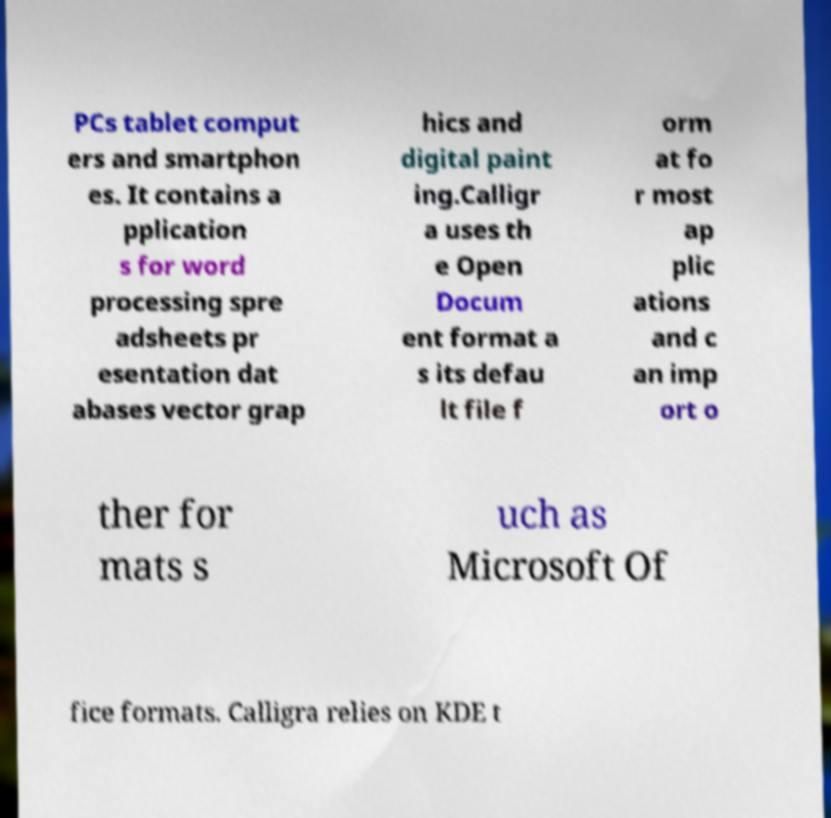Please read and relay the text visible in this image. What does it say? PCs tablet comput ers and smartphon es. It contains a pplication s for word processing spre adsheets pr esentation dat abases vector grap hics and digital paint ing.Calligr a uses th e Open Docum ent format a s its defau lt file f orm at fo r most ap plic ations and c an imp ort o ther for mats s uch as Microsoft Of fice formats. Calligra relies on KDE t 